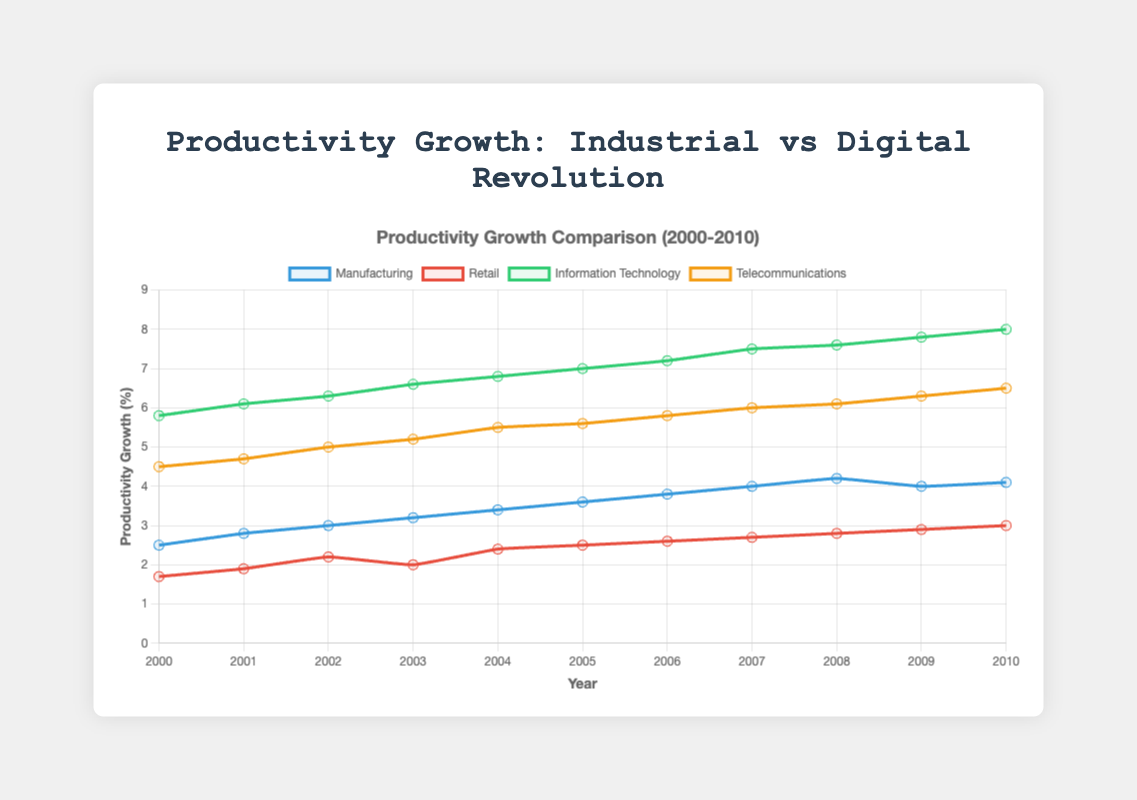What is the trend in productivity growth for manufacturing over the years 2000 to 2010? From the figure, we can see that the line representing manufacturing productivity growth increases steadily each year, starting at 2.5% in 2000 and reaching 4.1% in 2010.
Answer: Steady increase Which industry had the highest productivity growth in 2005? By looking at the plotted data points for the year 2005, the highest point belongs to the Information Technology line, indicating the highest productivity growth.
Answer: Information Technology What year saw the maximum productivity growth in telecommunications, and what was the value? Examining the yellow (or orange) line representing telecommunications, 2010 saw the maximum productivity growth, reaching a value of 6.5%.
Answer: 2010, 6.5% By how much did retail productivity growth increase from 2000 to 2010? In 2000, the retail productivity growth was 1.7%, and by 2010, it was 3.0%. Subtracting these values gives the increase: 3.0% - 1.7% = 1.3%.
Answer: 1.3% In which year did manufacturing productivity growth surpass 3%? Observing the blue line corresponding to manufacturing, it surpassed 3% in the year 2002.
Answer: 2002 Which industry consistently had the highest productivity growth across the entire time period? Checking the four lines, the green line representing Information Technology is consistently the highest through all the years from 2000 to 2010.
Answer: Information Technology Compare the productivity growth between retail and telecommunications in 2004. Which was higher, and by how much? In 2004, retail productivity growth was 2.4%, while telecommunications was 5.5%. Telecommunications was higher by 5.5% - 2.4% = 3.1%.
Answer: Telecommunications, 3.1% What is the average productivity growth in information technology over the years 2007 to 2010? For Information Technology, the productivity growth values from 2007 to 2010 are 7.5%, 7.6%, 7.8%, and 8.0%. Summing these values gives 30.9, and dividing by 4 (the number of years) results in an average of 30.9 / 4 = 7.725%.
Answer: 7.725% Which industry had the smallest productivity growth increase over the period 2000 to 2010, and what was the amount of increase? Comparing the smallest increases among the industries: Manufacturing (4.1%-2.5%= 1.6%), Retail (3.0%-1.7%= 1.3%), Information Technology (8.0%-5.8%= 2.2%), Telecommunications (6.5%-4.5% = 2.0%). Retail had the smallest increase of 1.3%.
Answer: Retail, 1.3% What was the difference in productivity growth between Information Technology and Manufacturing in 2010? In 2010, Information Technology had a productivity growth of 8.0%, and Manufacturing had 4.1%. The difference is 8.0% - 4.1% = 3.9%.
Answer: 3.9% 